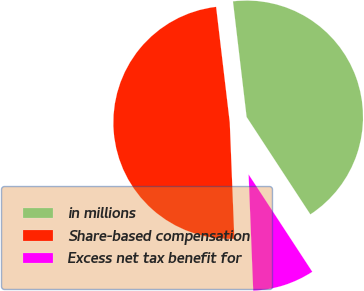<chart> <loc_0><loc_0><loc_500><loc_500><pie_chart><fcel>in millions<fcel>Share-based compensation<fcel>Excess net tax benefit for<nl><fcel>42.65%<fcel>48.76%<fcel>8.59%<nl></chart> 